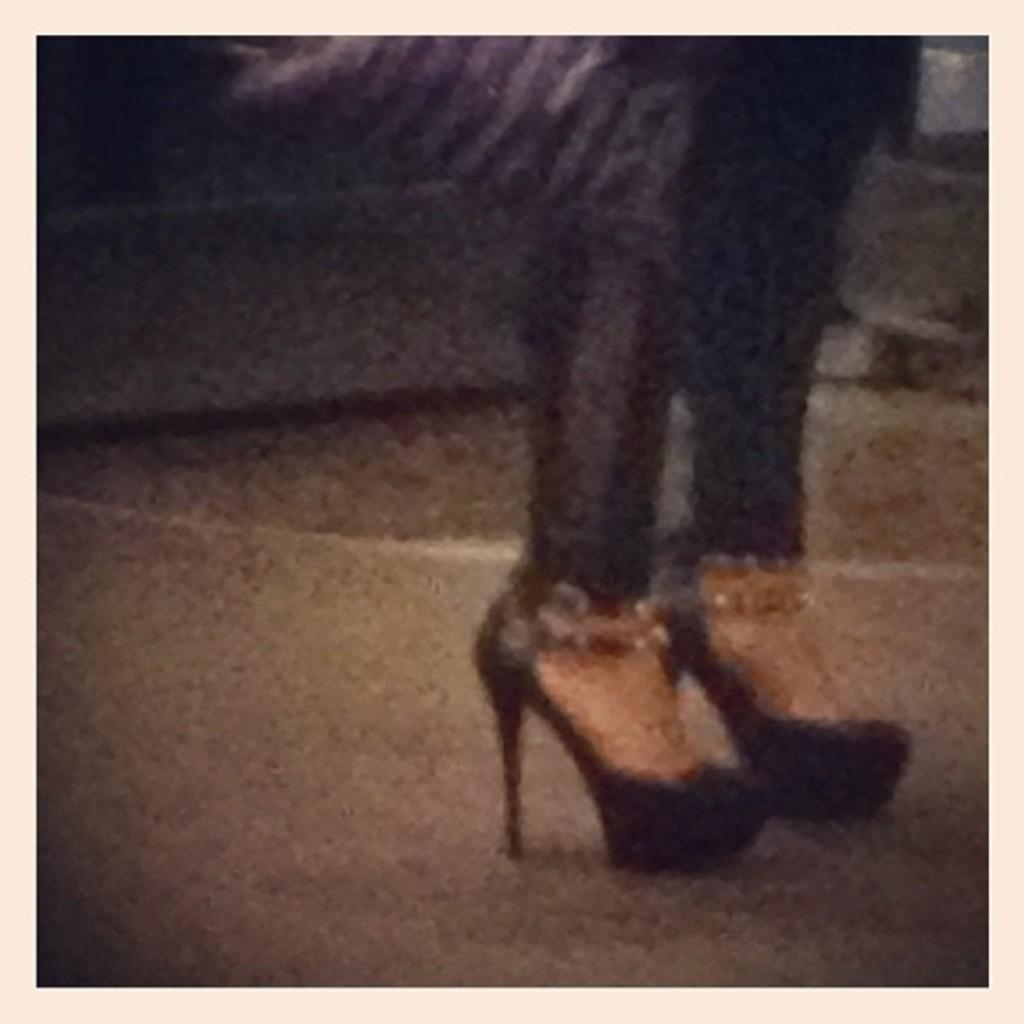What body part is visible in the image? The image contains legs of a person. What type of footwear is the person wearing? The person is wearing shoes. Is there a river flowing near the person's legs in the image? There is no river present in the image; it only shows the legs of a person wearing shoes. 